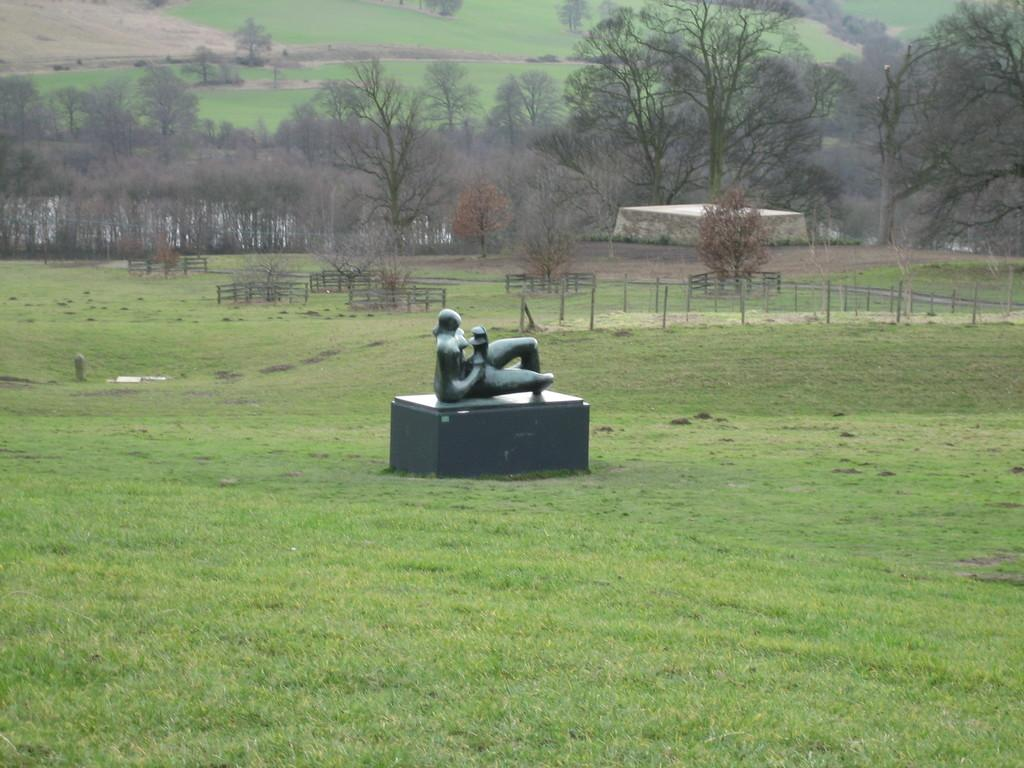What is located on the ground in the image? There is a sculpture on the ground in the image. What type of natural elements can be seen in the image? There are trees in the image. What man-made structures are present in the image? There are poles in the image. Can you describe the possible presence of water in the image? There may be water behind the tree on the left side of the image. What type of hair can be seen on the sculpture in the image? There is no hair present on the sculpture in the image. What offer is being made by the trees in the image? The trees in the image are not making any offers; they are simply part of the natural environment. 